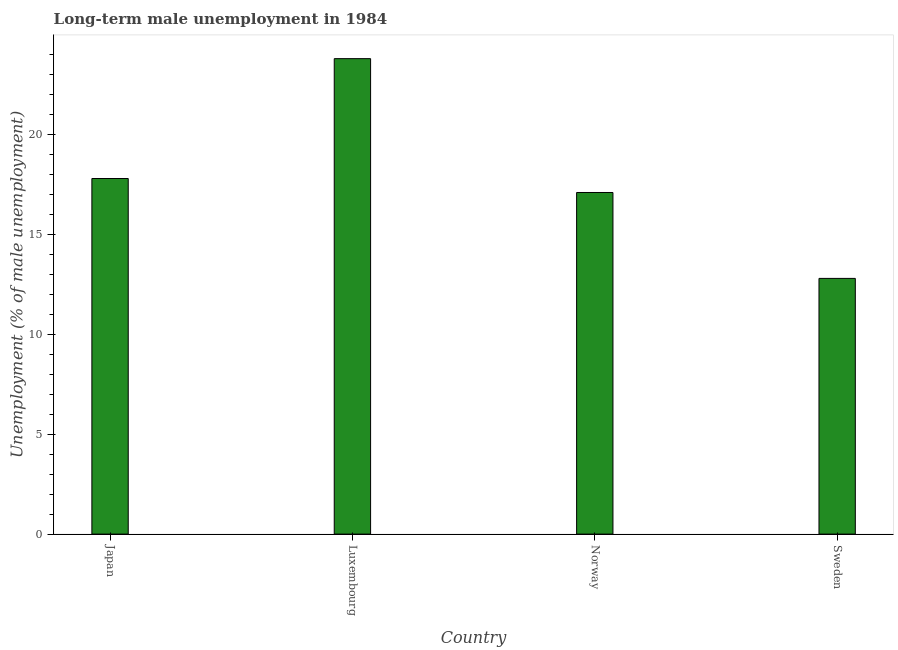Does the graph contain any zero values?
Offer a terse response. No. Does the graph contain grids?
Give a very brief answer. No. What is the title of the graph?
Your answer should be compact. Long-term male unemployment in 1984. What is the label or title of the Y-axis?
Offer a terse response. Unemployment (% of male unemployment). What is the long-term male unemployment in Japan?
Offer a very short reply. 17.8. Across all countries, what is the maximum long-term male unemployment?
Offer a terse response. 23.8. Across all countries, what is the minimum long-term male unemployment?
Give a very brief answer. 12.8. In which country was the long-term male unemployment maximum?
Ensure brevity in your answer.  Luxembourg. What is the sum of the long-term male unemployment?
Give a very brief answer. 71.5. What is the difference between the long-term male unemployment in Japan and Sweden?
Offer a very short reply. 5. What is the average long-term male unemployment per country?
Keep it short and to the point. 17.88. What is the median long-term male unemployment?
Give a very brief answer. 17.45. In how many countries, is the long-term male unemployment greater than 2 %?
Offer a very short reply. 4. What is the ratio of the long-term male unemployment in Japan to that in Luxembourg?
Make the answer very short. 0.75. Is the long-term male unemployment in Norway less than that in Sweden?
Provide a short and direct response. No. In how many countries, is the long-term male unemployment greater than the average long-term male unemployment taken over all countries?
Ensure brevity in your answer.  1. How many bars are there?
Your response must be concise. 4. What is the difference between two consecutive major ticks on the Y-axis?
Give a very brief answer. 5. What is the Unemployment (% of male unemployment) in Japan?
Offer a terse response. 17.8. What is the Unemployment (% of male unemployment) in Luxembourg?
Your answer should be very brief. 23.8. What is the Unemployment (% of male unemployment) of Norway?
Provide a succinct answer. 17.1. What is the Unemployment (% of male unemployment) of Sweden?
Ensure brevity in your answer.  12.8. What is the difference between the Unemployment (% of male unemployment) in Japan and Luxembourg?
Give a very brief answer. -6. What is the difference between the Unemployment (% of male unemployment) in Japan and Sweden?
Your response must be concise. 5. What is the difference between the Unemployment (% of male unemployment) in Norway and Sweden?
Provide a succinct answer. 4.3. What is the ratio of the Unemployment (% of male unemployment) in Japan to that in Luxembourg?
Provide a succinct answer. 0.75. What is the ratio of the Unemployment (% of male unemployment) in Japan to that in Norway?
Give a very brief answer. 1.04. What is the ratio of the Unemployment (% of male unemployment) in Japan to that in Sweden?
Ensure brevity in your answer.  1.39. What is the ratio of the Unemployment (% of male unemployment) in Luxembourg to that in Norway?
Your response must be concise. 1.39. What is the ratio of the Unemployment (% of male unemployment) in Luxembourg to that in Sweden?
Your response must be concise. 1.86. What is the ratio of the Unemployment (% of male unemployment) in Norway to that in Sweden?
Give a very brief answer. 1.34. 